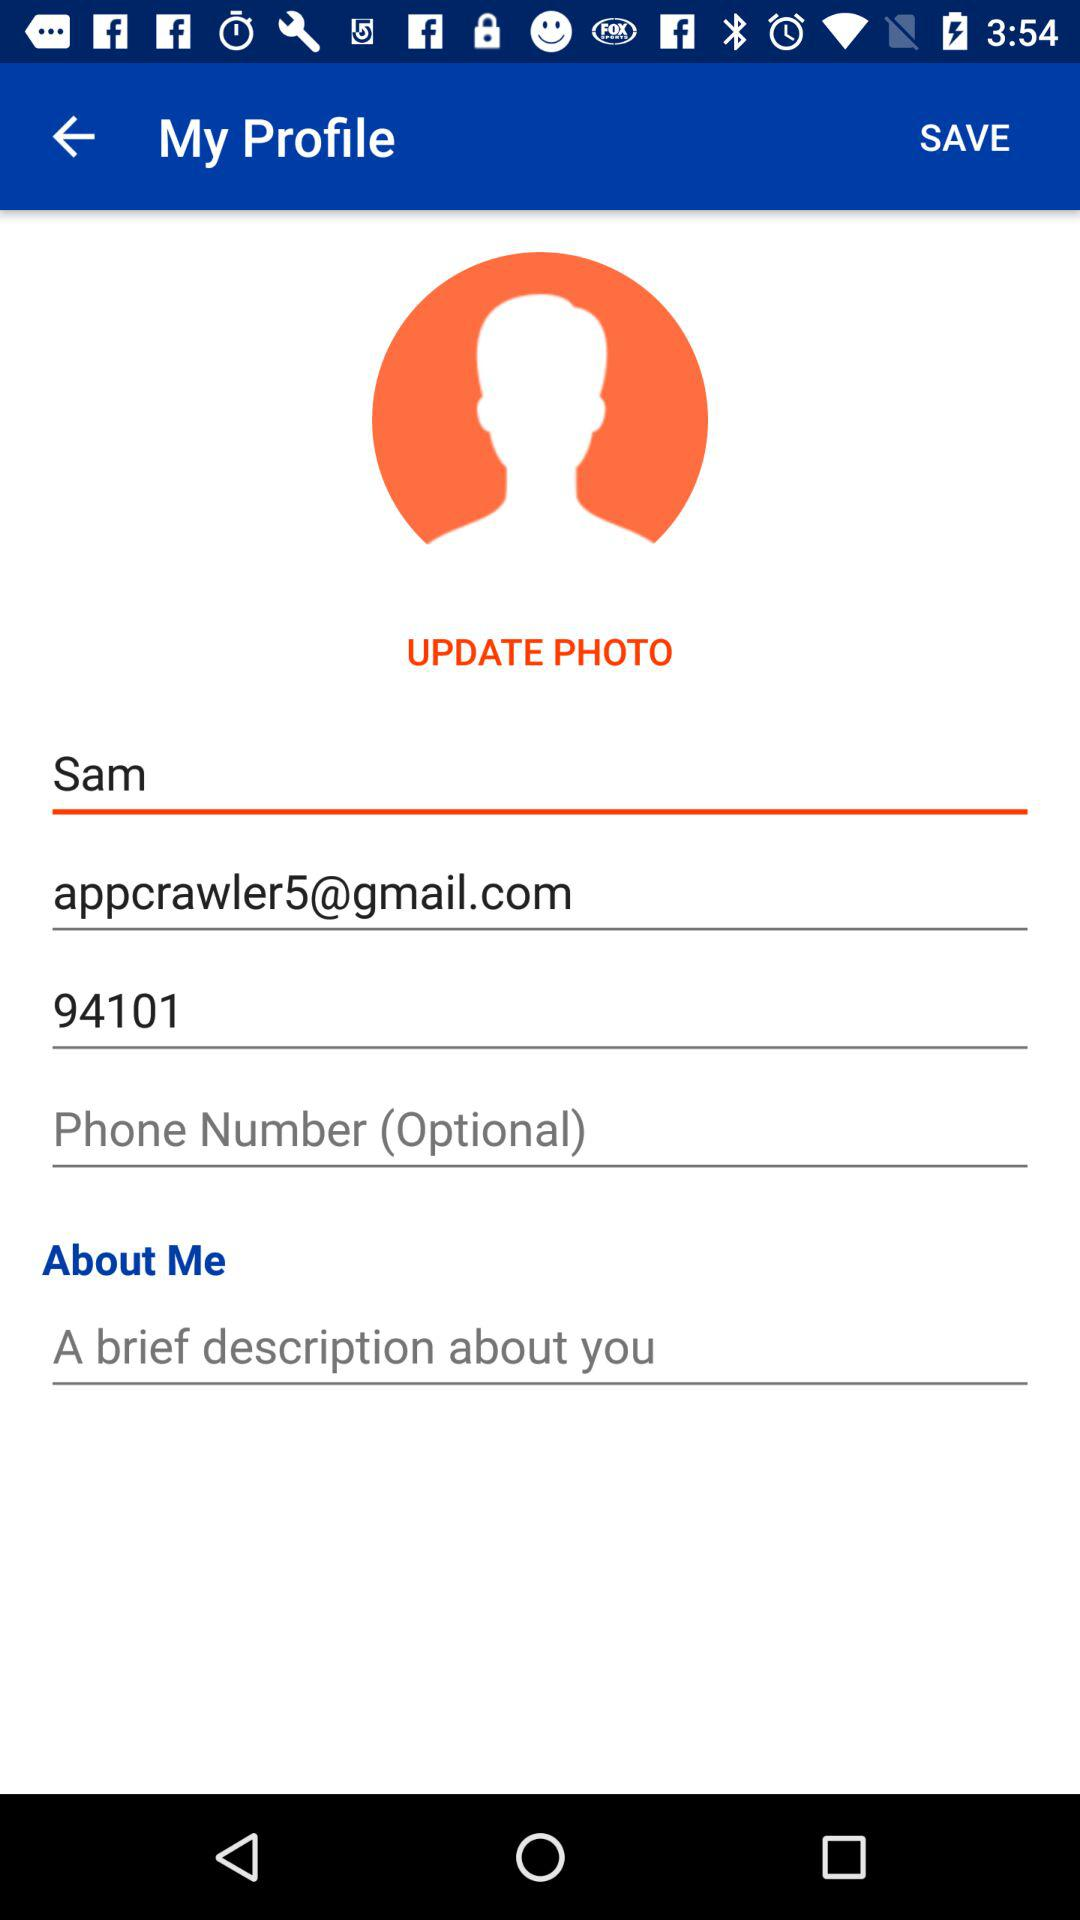What is the email address? The email address is appcrawler5@gmail.com. 